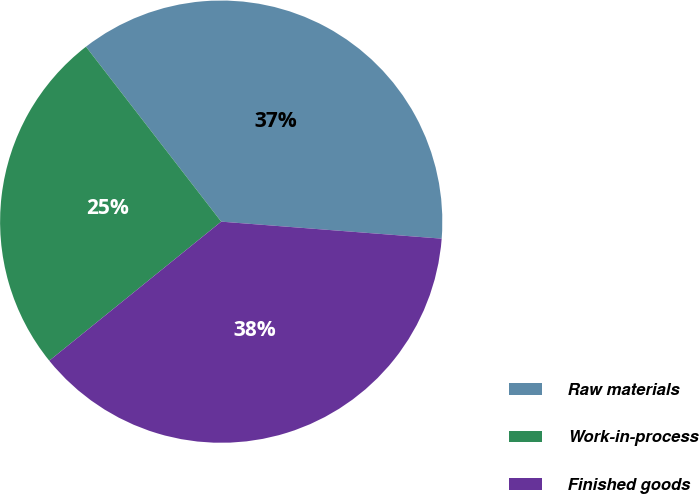Convert chart. <chart><loc_0><loc_0><loc_500><loc_500><pie_chart><fcel>Raw materials<fcel>Work-in-process<fcel>Finished goods<nl><fcel>36.7%<fcel>25.35%<fcel>37.95%<nl></chart> 